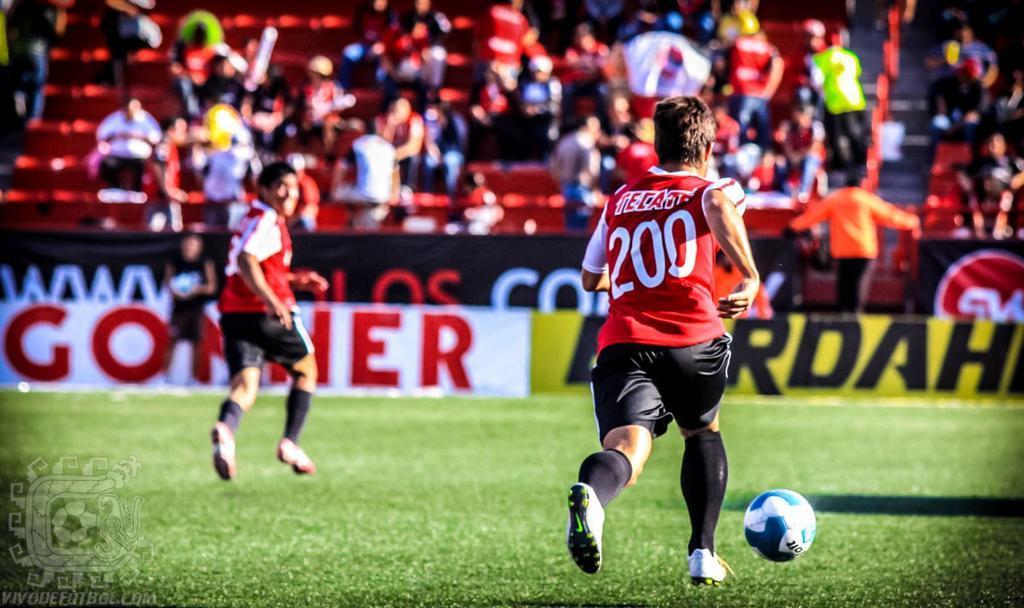Please provide a concise description of this image. This image consists of many people in the background. In the front, there are two men playing football. At the bottom, there is green grass. 